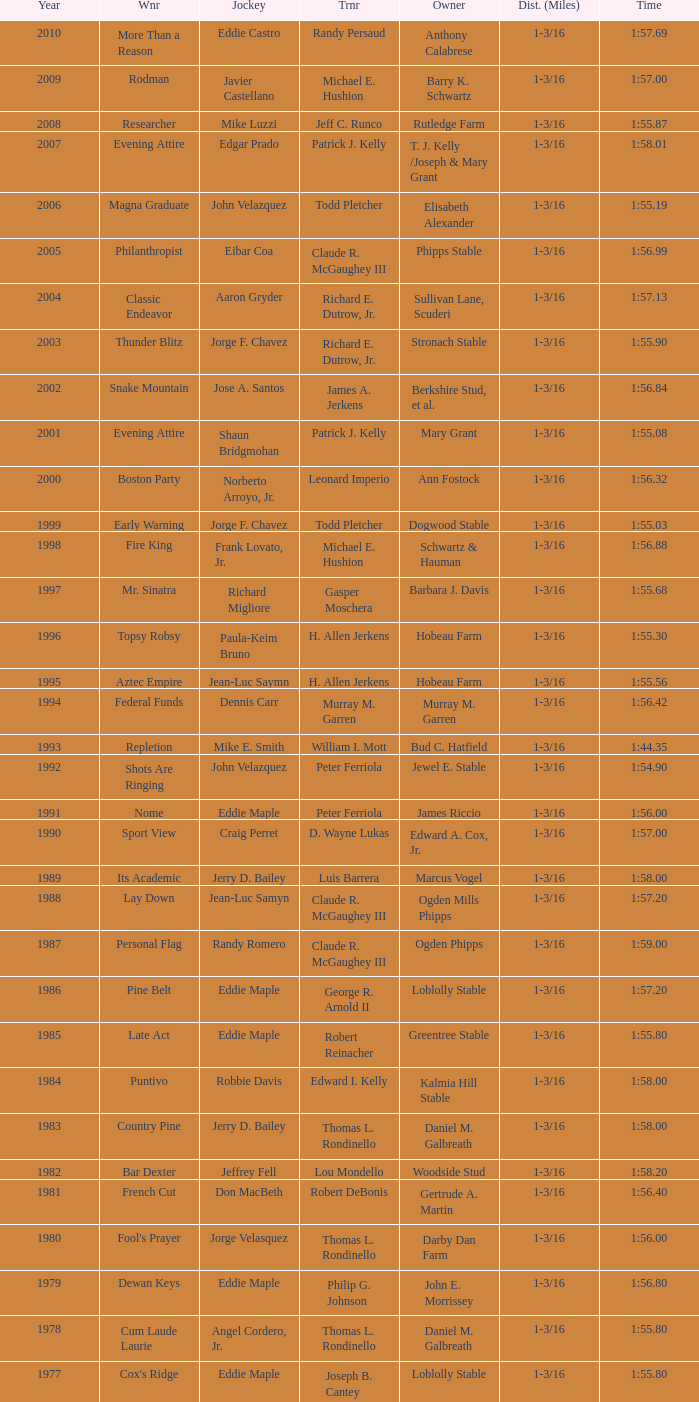Who was the jockey for the winning horse Helioptic? Paul Miller. 